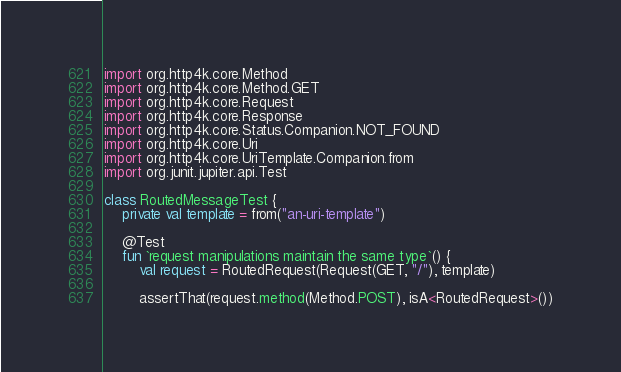<code> <loc_0><loc_0><loc_500><loc_500><_Kotlin_>import org.http4k.core.Method
import org.http4k.core.Method.GET
import org.http4k.core.Request
import org.http4k.core.Response
import org.http4k.core.Status.Companion.NOT_FOUND
import org.http4k.core.Uri
import org.http4k.core.UriTemplate.Companion.from
import org.junit.jupiter.api.Test

class RoutedMessageTest {
    private val template = from("an-uri-template")

    @Test
    fun `request manipulations maintain the same type`() {
        val request = RoutedRequest(Request(GET, "/"), template)

        assertThat(request.method(Method.POST), isA<RoutedRequest>())</code> 